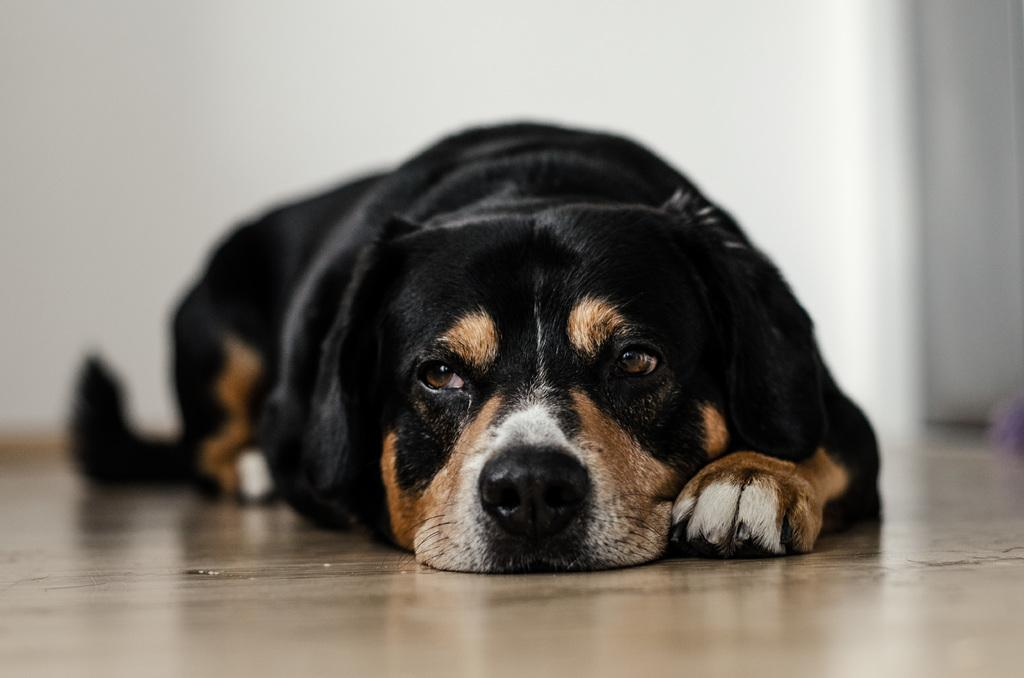What type of animal is in the image? There is a dog in the image. Where is the dog located? The dog is on the floor. What can be seen in the background of the image? There is a wall visible in the background of the image. What game is the dog playing with the wall in the image? There is no game being played in the image; the dog is simply on the floor and the wall is in the background. 